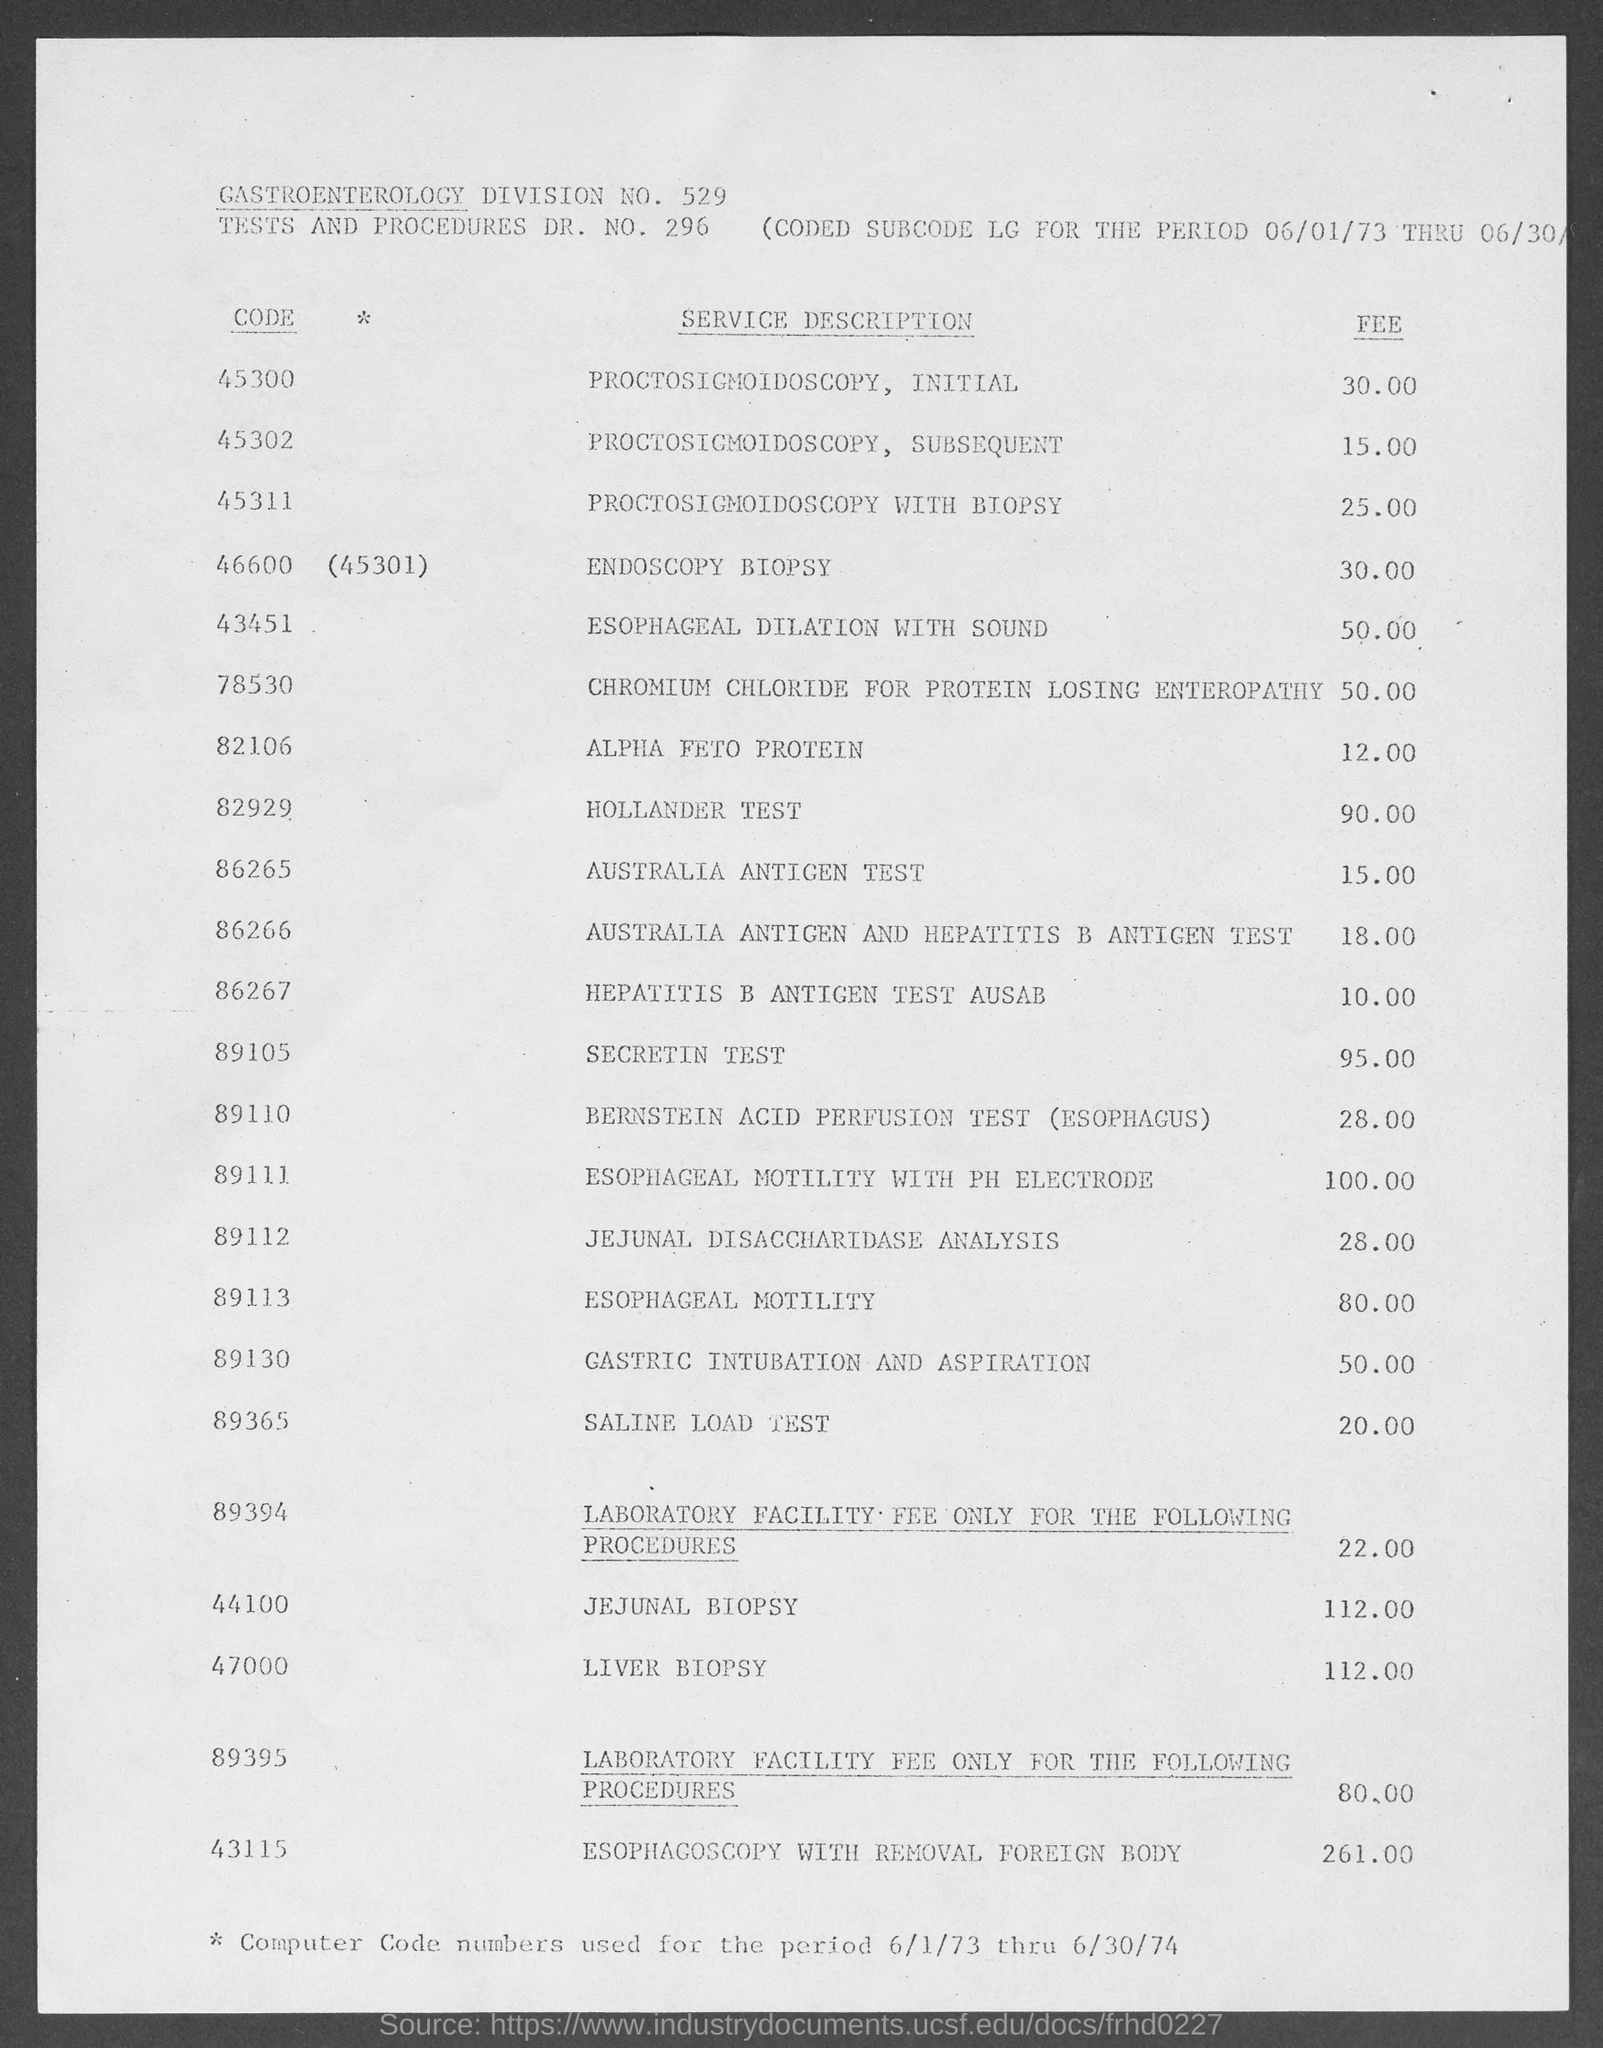Outline some significant characteristics in this image. The fee charged for a Saline Load Test is 20.00. The code for a liver biopsy is 47000. The Gastroenterology Division number mentioned in the document is 529. The fee charged for a Secretin Test is $95.00. The Hollander test code is 82929. 